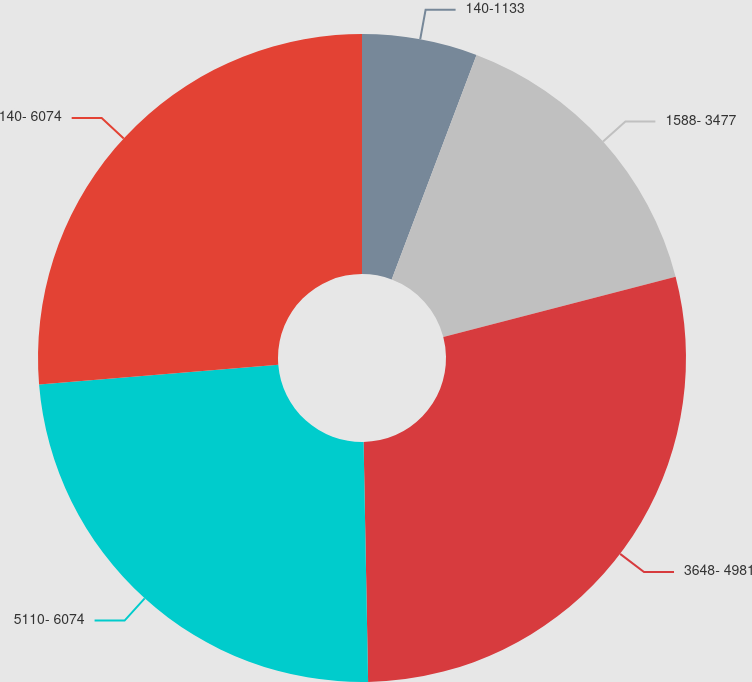Convert chart to OTSL. <chart><loc_0><loc_0><loc_500><loc_500><pie_chart><fcel>140-1133<fcel>1588- 3477<fcel>3648- 4981<fcel>5110- 6074<fcel>140- 6074<nl><fcel>5.75%<fcel>15.21%<fcel>28.74%<fcel>24.0%<fcel>26.3%<nl></chart> 